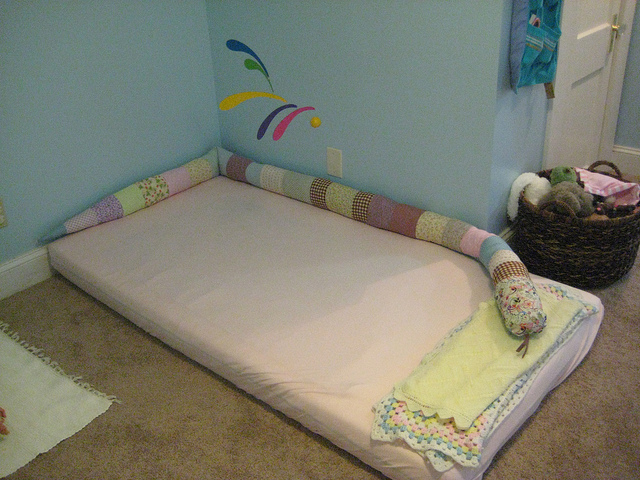<image>What color is the border on the folded blanket? I am not sure. The color of the border on the folded blanket can be yellow, pink, green, light blue, or white. What color is the border on the folded blanket? I don't know what color the border on the folded blanket is. It could be yellow, pink, green, light blue, white, or yellow. 